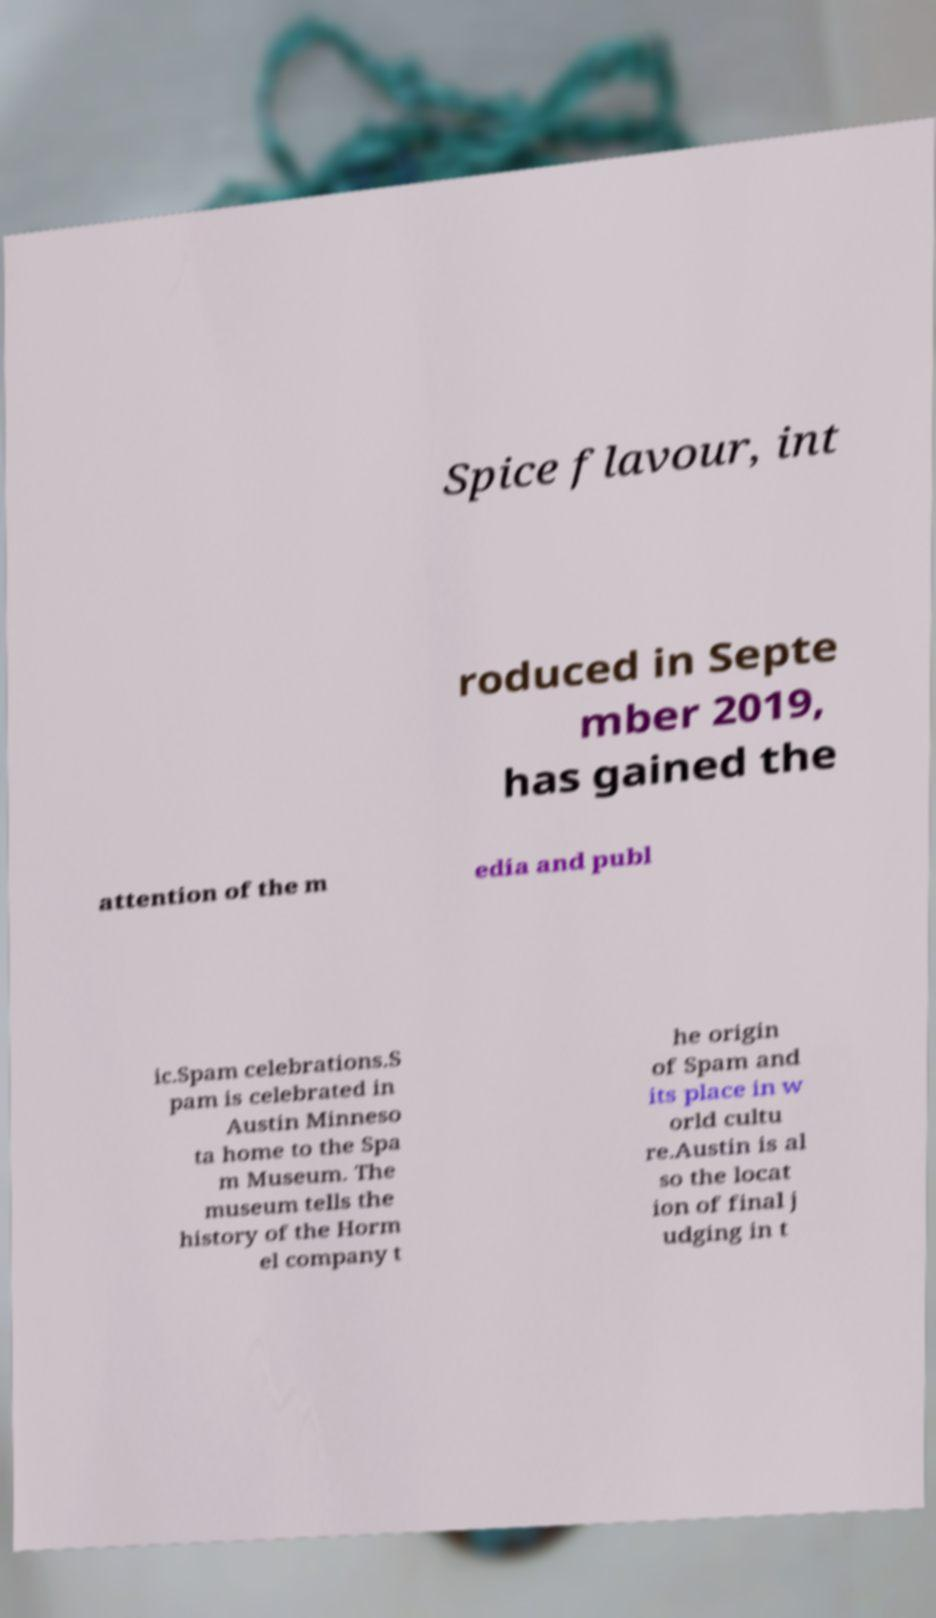I need the written content from this picture converted into text. Can you do that? Spice flavour, int roduced in Septe mber 2019, has gained the attention of the m edia and publ ic.Spam celebrations.S pam is celebrated in Austin Minneso ta home to the Spa m Museum. The museum tells the history of the Horm el company t he origin of Spam and its place in w orld cultu re.Austin is al so the locat ion of final j udging in t 